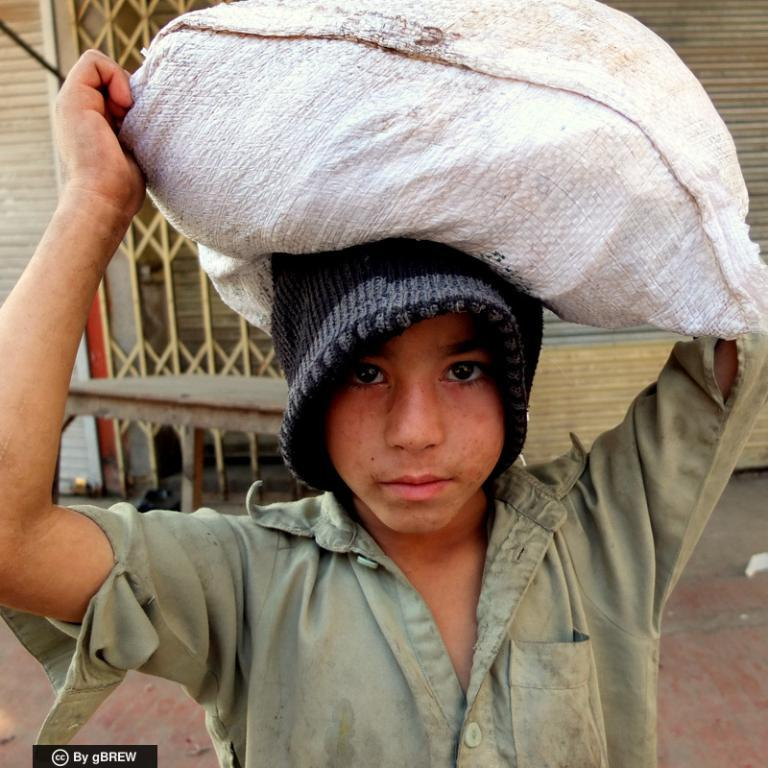Who is the main subject in the image? There is a boy in the image. What is the boy wearing on his upper body? The boy is wearing a green shirt. What is the boy wearing on his head? The boy is wearing a black cap and holding a white cap on his head. What can be seen in the background of the image? There is a shop in the background of the image. How many patches can be seen on the boy's shirt in the image? There are no patches visible on the boy's shirt in the image. What type of tomatoes are being sold at the shop in the image? There is no indication of any tomatoes being sold at the shop in the image. 